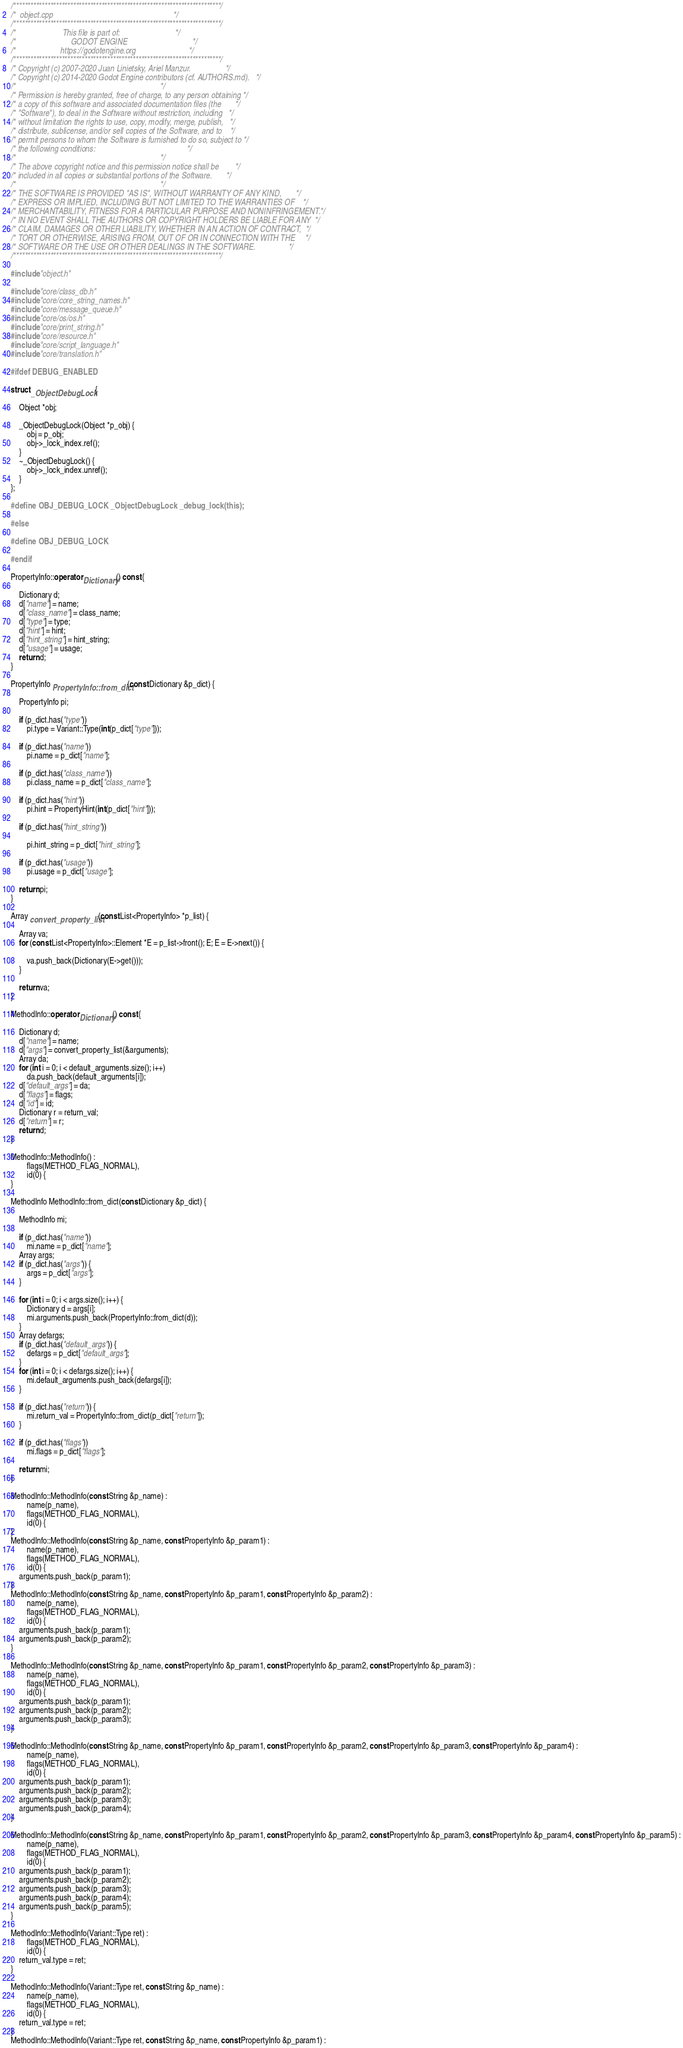Convert code to text. <code><loc_0><loc_0><loc_500><loc_500><_C++_>/*************************************************************************/
/*  object.cpp                                                           */
/*************************************************************************/
/*                       This file is part of:                           */
/*                           GODOT ENGINE                                */
/*                      https://godotengine.org                          */
/*************************************************************************/
/* Copyright (c) 2007-2020 Juan Linietsky, Ariel Manzur.                 */
/* Copyright (c) 2014-2020 Godot Engine contributors (cf. AUTHORS.md).   */
/*                                                                       */
/* Permission is hereby granted, free of charge, to any person obtaining */
/* a copy of this software and associated documentation files (the       */
/* "Software"), to deal in the Software without restriction, including   */
/* without limitation the rights to use, copy, modify, merge, publish,   */
/* distribute, sublicense, and/or sell copies of the Software, and to    */
/* permit persons to whom the Software is furnished to do so, subject to */
/* the following conditions:                                             */
/*                                                                       */
/* The above copyright notice and this permission notice shall be        */
/* included in all copies or substantial portions of the Software.       */
/*                                                                       */
/* THE SOFTWARE IS PROVIDED "AS IS", WITHOUT WARRANTY OF ANY KIND,       */
/* EXPRESS OR IMPLIED, INCLUDING BUT NOT LIMITED TO THE WARRANTIES OF    */
/* MERCHANTABILITY, FITNESS FOR A PARTICULAR PURPOSE AND NONINFRINGEMENT.*/
/* IN NO EVENT SHALL THE AUTHORS OR COPYRIGHT HOLDERS BE LIABLE FOR ANY  */
/* CLAIM, DAMAGES OR OTHER LIABILITY, WHETHER IN AN ACTION OF CONTRACT,  */
/* TORT OR OTHERWISE, ARISING FROM, OUT OF OR IN CONNECTION WITH THE     */
/* SOFTWARE OR THE USE OR OTHER DEALINGS IN THE SOFTWARE.                */
/*************************************************************************/

#include "object.h"

#include "core/class_db.h"
#include "core/core_string_names.h"
#include "core/message_queue.h"
#include "core/os/os.h"
#include "core/print_string.h"
#include "core/resource.h"
#include "core/script_language.h"
#include "core/translation.h"

#ifdef DEBUG_ENABLED

struct _ObjectDebugLock {

	Object *obj;

	_ObjectDebugLock(Object *p_obj) {
		obj = p_obj;
		obj->_lock_index.ref();
	}
	~_ObjectDebugLock() {
		obj->_lock_index.unref();
	}
};

#define OBJ_DEBUG_LOCK _ObjectDebugLock _debug_lock(this);

#else

#define OBJ_DEBUG_LOCK

#endif

PropertyInfo::operator Dictionary() const {

	Dictionary d;
	d["name"] = name;
	d["class_name"] = class_name;
	d["type"] = type;
	d["hint"] = hint;
	d["hint_string"] = hint_string;
	d["usage"] = usage;
	return d;
}

PropertyInfo PropertyInfo::from_dict(const Dictionary &p_dict) {

	PropertyInfo pi;

	if (p_dict.has("type"))
		pi.type = Variant::Type(int(p_dict["type"]));

	if (p_dict.has("name"))
		pi.name = p_dict["name"];

	if (p_dict.has("class_name"))
		pi.class_name = p_dict["class_name"];

	if (p_dict.has("hint"))
		pi.hint = PropertyHint(int(p_dict["hint"]));

	if (p_dict.has("hint_string"))

		pi.hint_string = p_dict["hint_string"];

	if (p_dict.has("usage"))
		pi.usage = p_dict["usage"];

	return pi;
}

Array convert_property_list(const List<PropertyInfo> *p_list) {

	Array va;
	for (const List<PropertyInfo>::Element *E = p_list->front(); E; E = E->next()) {

		va.push_back(Dictionary(E->get()));
	}

	return va;
}

MethodInfo::operator Dictionary() const {

	Dictionary d;
	d["name"] = name;
	d["args"] = convert_property_list(&arguments);
	Array da;
	for (int i = 0; i < default_arguments.size(); i++)
		da.push_back(default_arguments[i]);
	d["default_args"] = da;
	d["flags"] = flags;
	d["id"] = id;
	Dictionary r = return_val;
	d["return"] = r;
	return d;
}

MethodInfo::MethodInfo() :
		flags(METHOD_FLAG_NORMAL),
		id(0) {
}

MethodInfo MethodInfo::from_dict(const Dictionary &p_dict) {

	MethodInfo mi;

	if (p_dict.has("name"))
		mi.name = p_dict["name"];
	Array args;
	if (p_dict.has("args")) {
		args = p_dict["args"];
	}

	for (int i = 0; i < args.size(); i++) {
		Dictionary d = args[i];
		mi.arguments.push_back(PropertyInfo::from_dict(d));
	}
	Array defargs;
	if (p_dict.has("default_args")) {
		defargs = p_dict["default_args"];
	}
	for (int i = 0; i < defargs.size(); i++) {
		mi.default_arguments.push_back(defargs[i]);
	}

	if (p_dict.has("return")) {
		mi.return_val = PropertyInfo::from_dict(p_dict["return"]);
	}

	if (p_dict.has("flags"))
		mi.flags = p_dict["flags"];

	return mi;
}

MethodInfo::MethodInfo(const String &p_name) :
		name(p_name),
		flags(METHOD_FLAG_NORMAL),
		id(0) {
}
MethodInfo::MethodInfo(const String &p_name, const PropertyInfo &p_param1) :
		name(p_name),
		flags(METHOD_FLAG_NORMAL),
		id(0) {
	arguments.push_back(p_param1);
}
MethodInfo::MethodInfo(const String &p_name, const PropertyInfo &p_param1, const PropertyInfo &p_param2) :
		name(p_name),
		flags(METHOD_FLAG_NORMAL),
		id(0) {
	arguments.push_back(p_param1);
	arguments.push_back(p_param2);
}

MethodInfo::MethodInfo(const String &p_name, const PropertyInfo &p_param1, const PropertyInfo &p_param2, const PropertyInfo &p_param3) :
		name(p_name),
		flags(METHOD_FLAG_NORMAL),
		id(0) {
	arguments.push_back(p_param1);
	arguments.push_back(p_param2);
	arguments.push_back(p_param3);
}

MethodInfo::MethodInfo(const String &p_name, const PropertyInfo &p_param1, const PropertyInfo &p_param2, const PropertyInfo &p_param3, const PropertyInfo &p_param4) :
		name(p_name),
		flags(METHOD_FLAG_NORMAL),
		id(0) {
	arguments.push_back(p_param1);
	arguments.push_back(p_param2);
	arguments.push_back(p_param3);
	arguments.push_back(p_param4);
}

MethodInfo::MethodInfo(const String &p_name, const PropertyInfo &p_param1, const PropertyInfo &p_param2, const PropertyInfo &p_param3, const PropertyInfo &p_param4, const PropertyInfo &p_param5) :
		name(p_name),
		flags(METHOD_FLAG_NORMAL),
		id(0) {
	arguments.push_back(p_param1);
	arguments.push_back(p_param2);
	arguments.push_back(p_param3);
	arguments.push_back(p_param4);
	arguments.push_back(p_param5);
}

MethodInfo::MethodInfo(Variant::Type ret) :
		flags(METHOD_FLAG_NORMAL),
		id(0) {
	return_val.type = ret;
}

MethodInfo::MethodInfo(Variant::Type ret, const String &p_name) :
		name(p_name),
		flags(METHOD_FLAG_NORMAL),
		id(0) {
	return_val.type = ret;
}
MethodInfo::MethodInfo(Variant::Type ret, const String &p_name, const PropertyInfo &p_param1) :</code> 